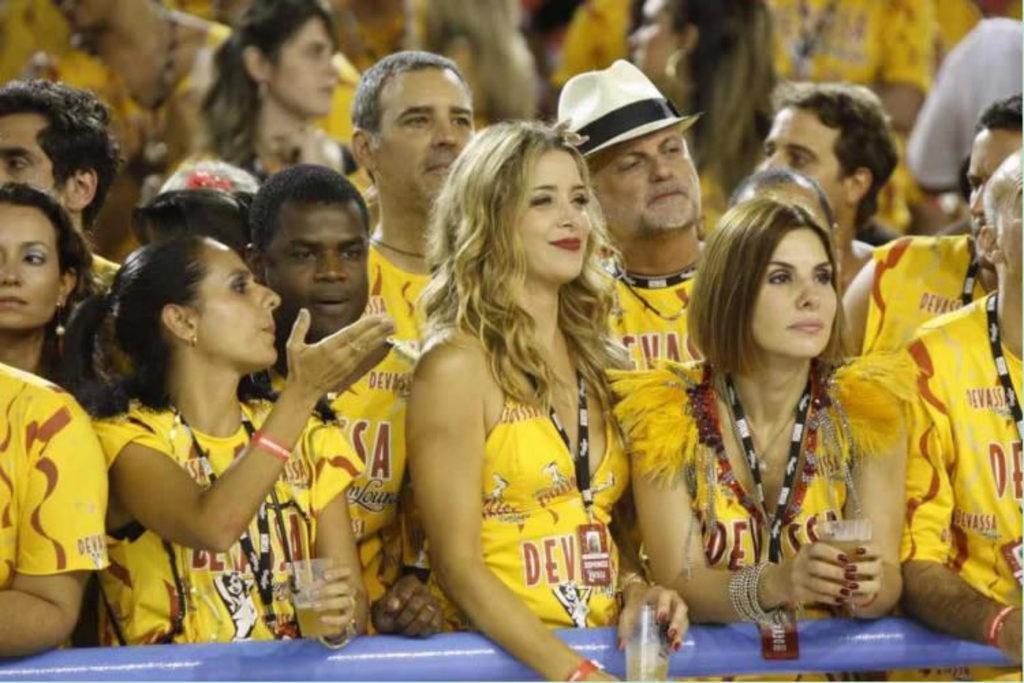How would you summarize this image in a sentence or two? In this image there are people standing few are holding glasses in their hands. 